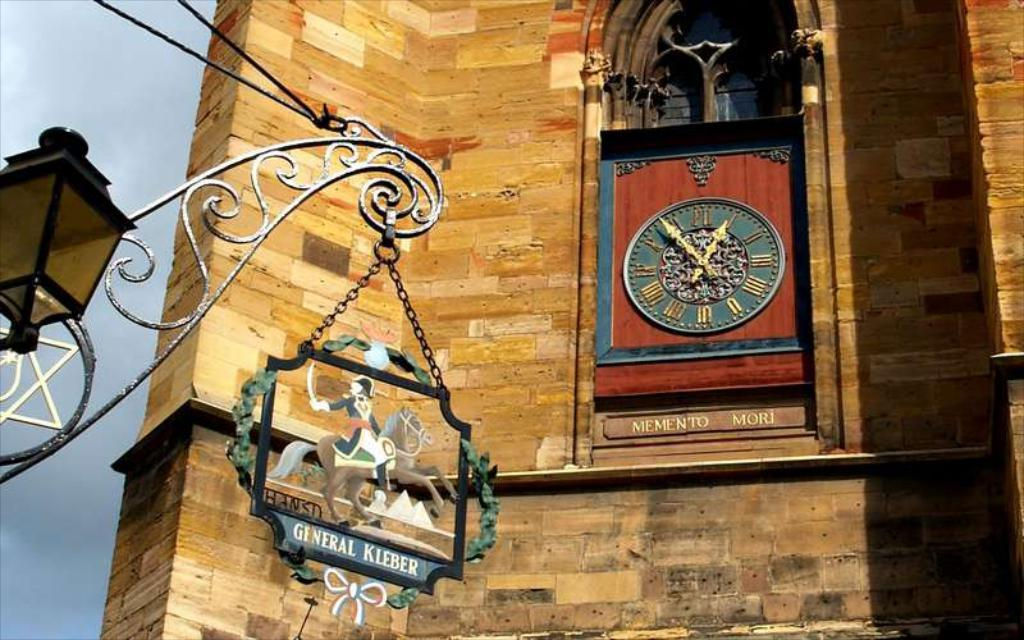<image>
Present a compact description of the photo's key features. medieval sign noting General Kleber and a clock with dedication 